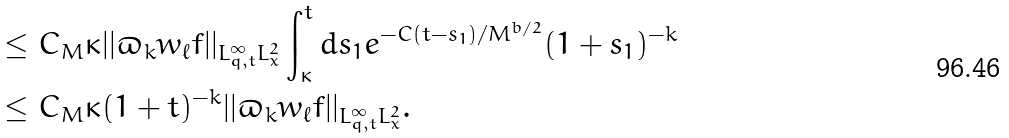<formula> <loc_0><loc_0><loc_500><loc_500>& \leq C _ { M } \kappa | | \varpi _ { k } w _ { \ell } f | | _ { L ^ { \infty } _ { q , t } L ^ { 2 } _ { x } } \int _ { \kappa } ^ { t } d s _ { 1 } e ^ { - C ( t - s _ { 1 } ) / M ^ { b / 2 } } ( 1 + s _ { 1 } ) ^ { - k } \\ & \leq C _ { M } \kappa ( 1 + t ) ^ { - k } | | \varpi _ { k } w _ { \ell } f | | _ { L ^ { \infty } _ { q , t } L ^ { 2 } _ { x } } .</formula> 